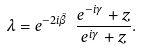<formula> <loc_0><loc_0><loc_500><loc_500>\lambda = e ^ { - 2 i \tilde { \beta } } \ \frac { e ^ { - i \gamma } + z } { e ^ { i \gamma } + z } .</formula> 